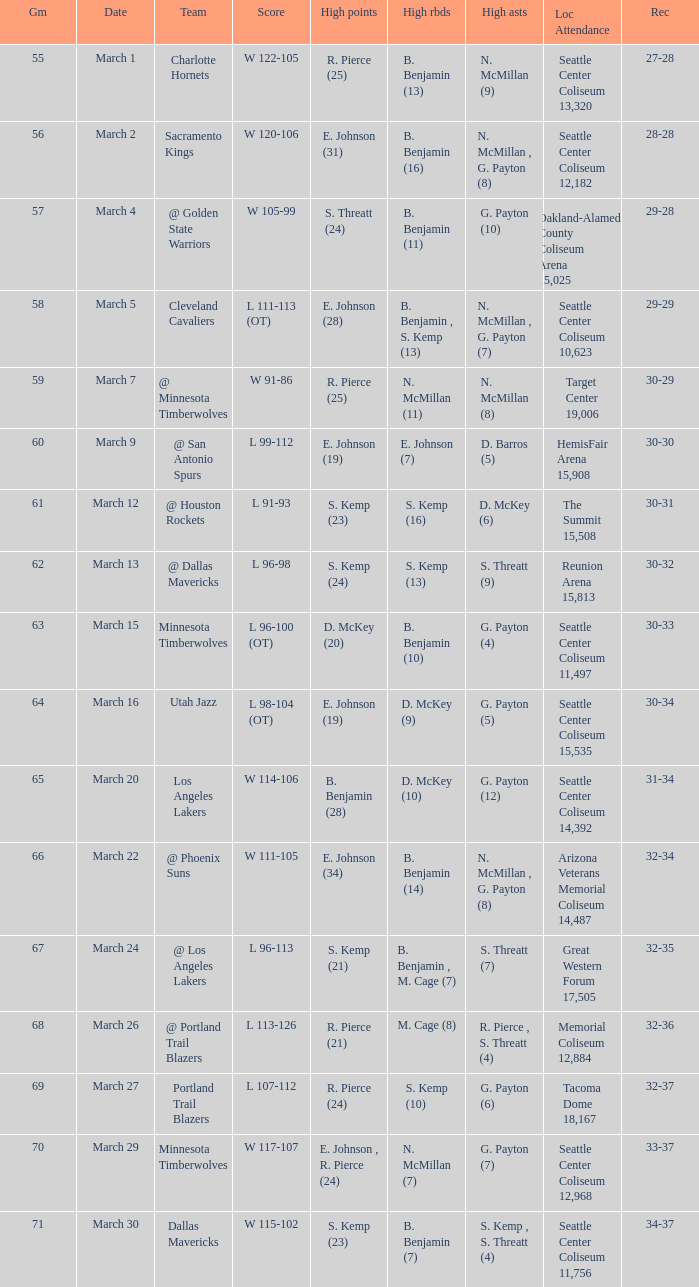Which Game has a Team of portland trail blazers? 69.0. Could you help me parse every detail presented in this table? {'header': ['Gm', 'Date', 'Team', 'Score', 'High points', 'High rbds', 'High asts', 'Loc Attendance', 'Rec'], 'rows': [['55', 'March 1', 'Charlotte Hornets', 'W 122-105', 'R. Pierce (25)', 'B. Benjamin (13)', 'N. McMillan (9)', 'Seattle Center Coliseum 13,320', '27-28'], ['56', 'March 2', 'Sacramento Kings', 'W 120-106', 'E. Johnson (31)', 'B. Benjamin (16)', 'N. McMillan , G. Payton (8)', 'Seattle Center Coliseum 12,182', '28-28'], ['57', 'March 4', '@ Golden State Warriors', 'W 105-99', 'S. Threatt (24)', 'B. Benjamin (11)', 'G. Payton (10)', 'Oakland-Alameda County Coliseum Arena 15,025', '29-28'], ['58', 'March 5', 'Cleveland Cavaliers', 'L 111-113 (OT)', 'E. Johnson (28)', 'B. Benjamin , S. Kemp (13)', 'N. McMillan , G. Payton (7)', 'Seattle Center Coliseum 10,623', '29-29'], ['59', 'March 7', '@ Minnesota Timberwolves', 'W 91-86', 'R. Pierce (25)', 'N. McMillan (11)', 'N. McMillan (8)', 'Target Center 19,006', '30-29'], ['60', 'March 9', '@ San Antonio Spurs', 'L 99-112', 'E. Johnson (19)', 'E. Johnson (7)', 'D. Barros (5)', 'HemisFair Arena 15,908', '30-30'], ['61', 'March 12', '@ Houston Rockets', 'L 91-93', 'S. Kemp (23)', 'S. Kemp (16)', 'D. McKey (6)', 'The Summit 15,508', '30-31'], ['62', 'March 13', '@ Dallas Mavericks', 'L 96-98', 'S. Kemp (24)', 'S. Kemp (13)', 'S. Threatt (9)', 'Reunion Arena 15,813', '30-32'], ['63', 'March 15', 'Minnesota Timberwolves', 'L 96-100 (OT)', 'D. McKey (20)', 'B. Benjamin (10)', 'G. Payton (4)', 'Seattle Center Coliseum 11,497', '30-33'], ['64', 'March 16', 'Utah Jazz', 'L 98-104 (OT)', 'E. Johnson (19)', 'D. McKey (9)', 'G. Payton (5)', 'Seattle Center Coliseum 15,535', '30-34'], ['65', 'March 20', 'Los Angeles Lakers', 'W 114-106', 'B. Benjamin (28)', 'D. McKey (10)', 'G. Payton (12)', 'Seattle Center Coliseum 14,392', '31-34'], ['66', 'March 22', '@ Phoenix Suns', 'W 111-105', 'E. Johnson (34)', 'B. Benjamin (14)', 'N. McMillan , G. Payton (8)', 'Arizona Veterans Memorial Coliseum 14,487', '32-34'], ['67', 'March 24', '@ Los Angeles Lakers', 'L 96-113', 'S. Kemp (21)', 'B. Benjamin , M. Cage (7)', 'S. Threatt (7)', 'Great Western Forum 17,505', '32-35'], ['68', 'March 26', '@ Portland Trail Blazers', 'L 113-126', 'R. Pierce (21)', 'M. Cage (8)', 'R. Pierce , S. Threatt (4)', 'Memorial Coliseum 12,884', '32-36'], ['69', 'March 27', 'Portland Trail Blazers', 'L 107-112', 'R. Pierce (24)', 'S. Kemp (10)', 'G. Payton (6)', 'Tacoma Dome 18,167', '32-37'], ['70', 'March 29', 'Minnesota Timberwolves', 'W 117-107', 'E. Johnson , R. Pierce (24)', 'N. McMillan (7)', 'G. Payton (7)', 'Seattle Center Coliseum 12,968', '33-37'], ['71', 'March 30', 'Dallas Mavericks', 'W 115-102', 'S. Kemp (23)', 'B. Benjamin (7)', 'S. Kemp , S. Threatt (4)', 'Seattle Center Coliseum 11,756', '34-37']]} 